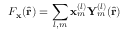<formula> <loc_0><loc_0><loc_500><loc_500>F _ { x } ( \hat { r } ) = \sum _ { l , m } x _ { m } ^ { ( l ) } Y _ { m } ^ { ( l ) } ( \hat { r } )</formula> 